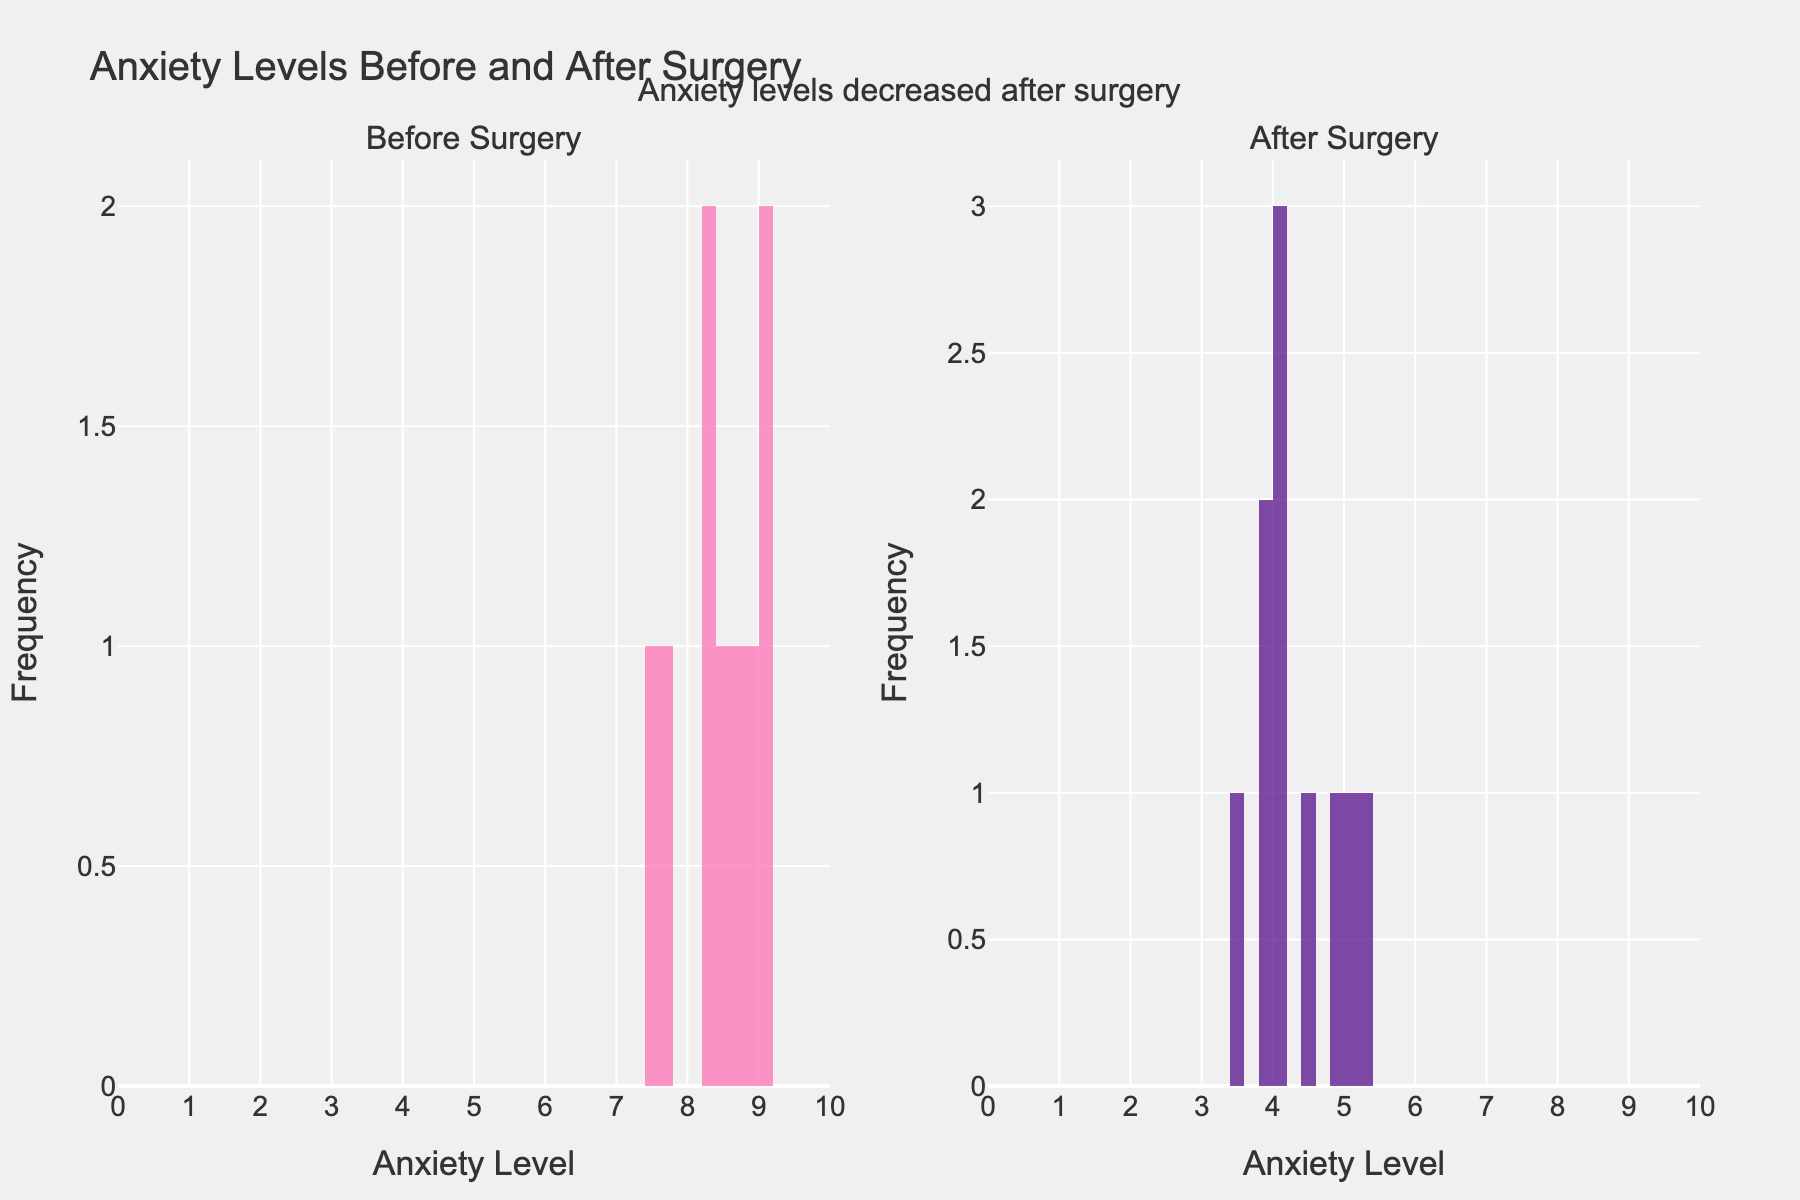What is the title of the plot? The title can be seen at the top of the figure, which reads "Anxiety Levels Before and After Surgery".
Answer: Anxiety Levels Before and After Surgery How many subplots are there in the figure? The figure is divided into two sections labeled "Before Surgery" and "After Surgery" at the top of each subplot.
Answer: 2 What is the highest recorded anxiety level before surgery? By examining the "Before Surgery" subplot, the histogram shows the highest bar ending at an anxiety level close to but less than 10.
Answer: 9.2 What is the range of anxiety levels displayed on the x-axes? Both subplots have x-axes labeled with a range from 0 to 10, which encompasses all the data points' anxiety levels.
Answer: 0 to 10 How do the colors differ between the two subplots? The histogram bars in the "Before Surgery" subplot are pink, and the bars in the "After Surgery" subplot are purple.
Answer: Pink and purple What is the average anxiety level decrease after surgery? To find the average decrease, subtract each 'Anxiety_Level_After_Surgery' from 'Anxiety_Level_Before_Surgery' for each mother, then find the average of those differences: (8.5-4.0 + 9.2-5.3 + 7.7-3.5 + 8.9-4.8 + 9.0-3.9 + 8.2-4.1 + 7.5-4.0 + 8.3-4.5 + 9.1-5.0 + 8.7-3.8) / 10 results in an average decrease.
Answer: 4.27 How does the frequency of the highest anxiety level after surgery compare to before surgery? In the "Before Surgery" histogram, the frequency of the highest anxiety levels (9.0 to 9.2) is shown with single bars, while in the "After Surgery" histogram, the highest frequency peak reaches a lower level around 5.3.
Answer: Higher before surgery Which subplot shows a higher frequency of lower anxiety levels? By comparing the frequencies of lower anxiety levels (closer to 0) in both histograms, the "After Surgery" subplot shows higher bars at the lower end, indicating more lower anxiety levels.
Answer: After Surgery What annotation is added to the figure? There is an annotation above the plot that states "Anxiety levels decreased after surgery".
Answer: Anxiety levels decreased after surgery 